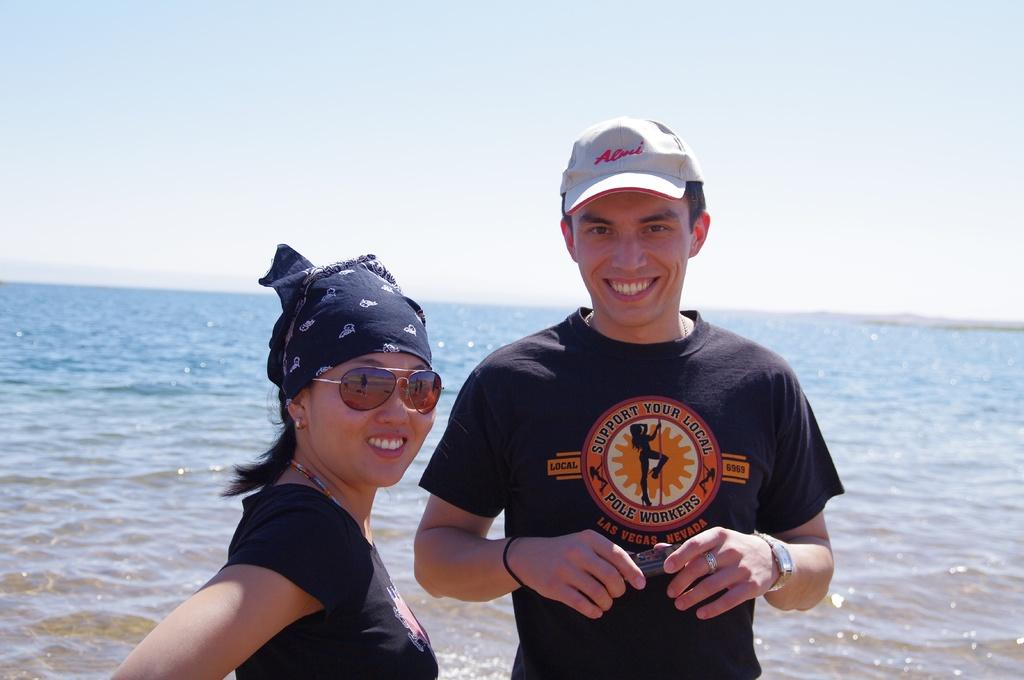How many people are present in the image? There are two people, a man and a woman, present in the image. What is the man holding in the image? The man is holding an object. What can be seen in the background of the image? There is a large water body and the sky visible in the background of the image. What is the condition of the sky in the image? The sky appears cloudy in the image. What type of humor can be seen in the image? There is no humor present in the image; it features a man, a woman, and a cloudy sky in the background. How many trains are visible in the image? There are no trains present in the image. 